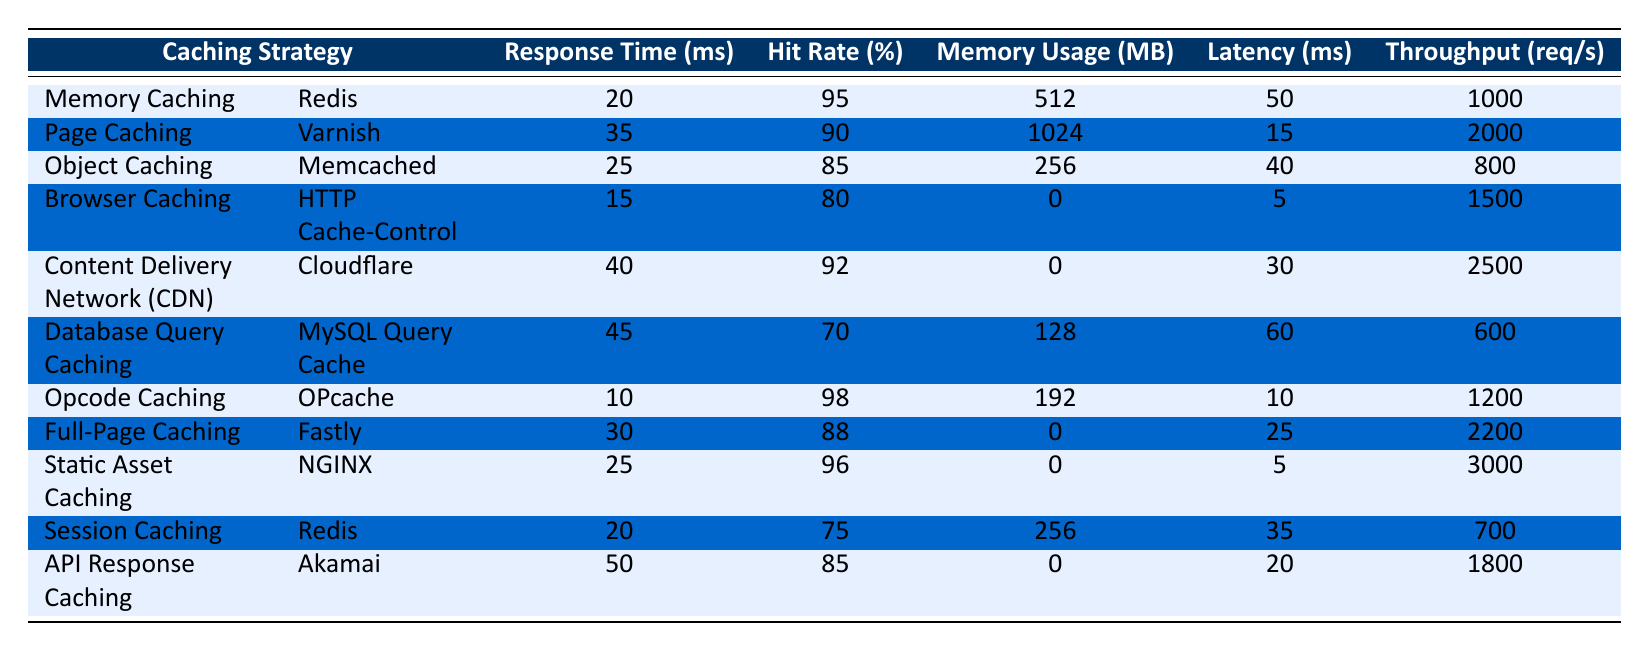What is the hit rate of Memory Caching? The hit rate for Memory Caching is directly stated in the table as 95%.
Answer: 95% Which caching strategy has the lowest response time? Scanning through the table, Opcode Caching has the lowest response time of 10 ms.
Answer: 10 ms What is the average memory usage of all caching strategies? Summing the memory usage values (512 + 1024 + 256 + 0 + 0 + 128 + 192 + 0 + 0 + 256) gives 2078 MB. There are 10 strategies, so dividing 2078 by 10 results in an average of 207.8 MB.
Answer: 207.8 MB Is the latency of Browser Caching less than that of Database Query Caching? The latency for Browser Caching is 5 ms and for Database Query Caching is 60 ms. Since 5 is less than 60, the statement is true.
Answer: Yes Which caching strategy provides the highest throughput? Checking the throughput values, Static Asset Caching has the highest throughput at 3000 req/s.
Answer: 3000 req/s What is the total throughput of all caching strategies? Adding the throughput values (1000 + 2000 + 800 + 1500 + 2500 + 600 + 1200 + 2200 + 3000 + 1800) results in a total of 15,600 req/s.
Answer: 15,600 req/s Does Opcode Caching use more memory than Object Caching? Opcode Caching uses 192 MB while Object Caching uses 256 MB. Since 192 is not more than 256, the statement is false.
Answer: No What is the difference in response time between the fastest and slowest caching strategies? The fastest caching strategy, Opcode Caching, has a response time of 10 ms, while the slowest, API Response Caching, has 50 ms. Thus, the difference is 50 - 10 = 40 ms.
Answer: 40 ms What percentage of caching strategies have a hit rate greater than 90%? The caching strategies with hit rates greater than 90% are Memory Caching (95%) and Opcode Caching (98%). Out of 10 strategies, that makes 2 out of 10 or 20%.
Answer: 20% Which caching strategy has the highest latency, and what is its value? By reviewing the table, Database Query Caching has the highest latency, which is 60 ms.
Answer: 60 ms What is the latency difference between Content Delivery Network and Static Asset Caching? The latency for Content Delivery Network is 30 ms, while for Static Asset Caching, it is 5 ms. The difference is therefore 30 - 5 = 25 ms.
Answer: 25 ms 